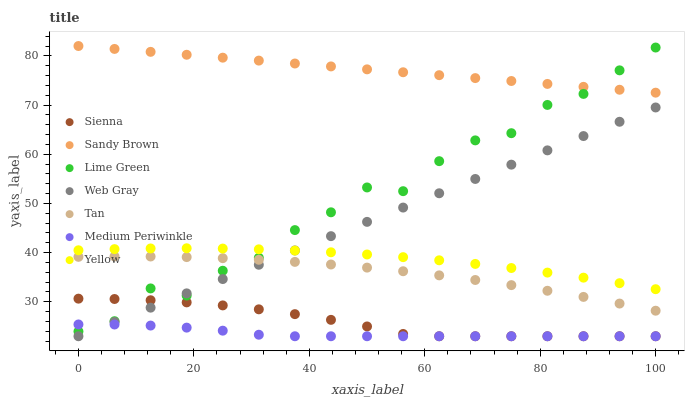Does Medium Periwinkle have the minimum area under the curve?
Answer yes or no. Yes. Does Sandy Brown have the maximum area under the curve?
Answer yes or no. Yes. Does Sandy Brown have the minimum area under the curve?
Answer yes or no. No. Does Medium Periwinkle have the maximum area under the curve?
Answer yes or no. No. Is Sandy Brown the smoothest?
Answer yes or no. Yes. Is Lime Green the roughest?
Answer yes or no. Yes. Is Medium Periwinkle the smoothest?
Answer yes or no. No. Is Medium Periwinkle the roughest?
Answer yes or no. No. Does Web Gray have the lowest value?
Answer yes or no. Yes. Does Sandy Brown have the lowest value?
Answer yes or no. No. Does Sandy Brown have the highest value?
Answer yes or no. Yes. Does Medium Periwinkle have the highest value?
Answer yes or no. No. Is Sienna less than Yellow?
Answer yes or no. Yes. Is Sandy Brown greater than Web Gray?
Answer yes or no. Yes. Does Sienna intersect Medium Periwinkle?
Answer yes or no. Yes. Is Sienna less than Medium Periwinkle?
Answer yes or no. No. Is Sienna greater than Medium Periwinkle?
Answer yes or no. No. Does Sienna intersect Yellow?
Answer yes or no. No. 